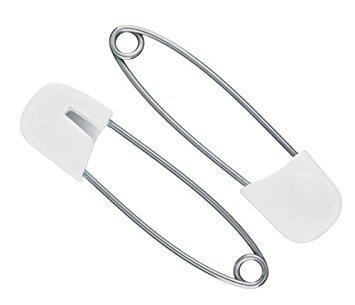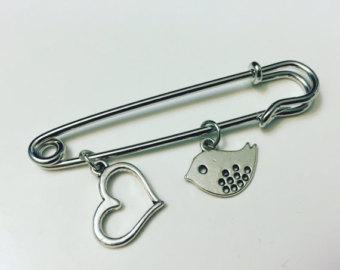The first image is the image on the left, the second image is the image on the right. For the images displayed, is the sentence "There are cloths pins grouped together with at least one of the pin tops colored white." factually correct? Answer yes or no. Yes. 